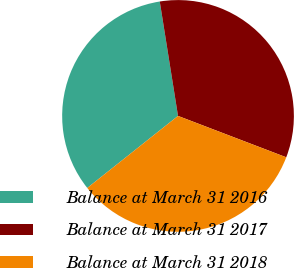Convert chart. <chart><loc_0><loc_0><loc_500><loc_500><pie_chart><fcel>Balance at March 31 2016<fcel>Balance at March 31 2017<fcel>Balance at March 31 2018<nl><fcel>33.16%<fcel>33.33%<fcel>33.51%<nl></chart> 